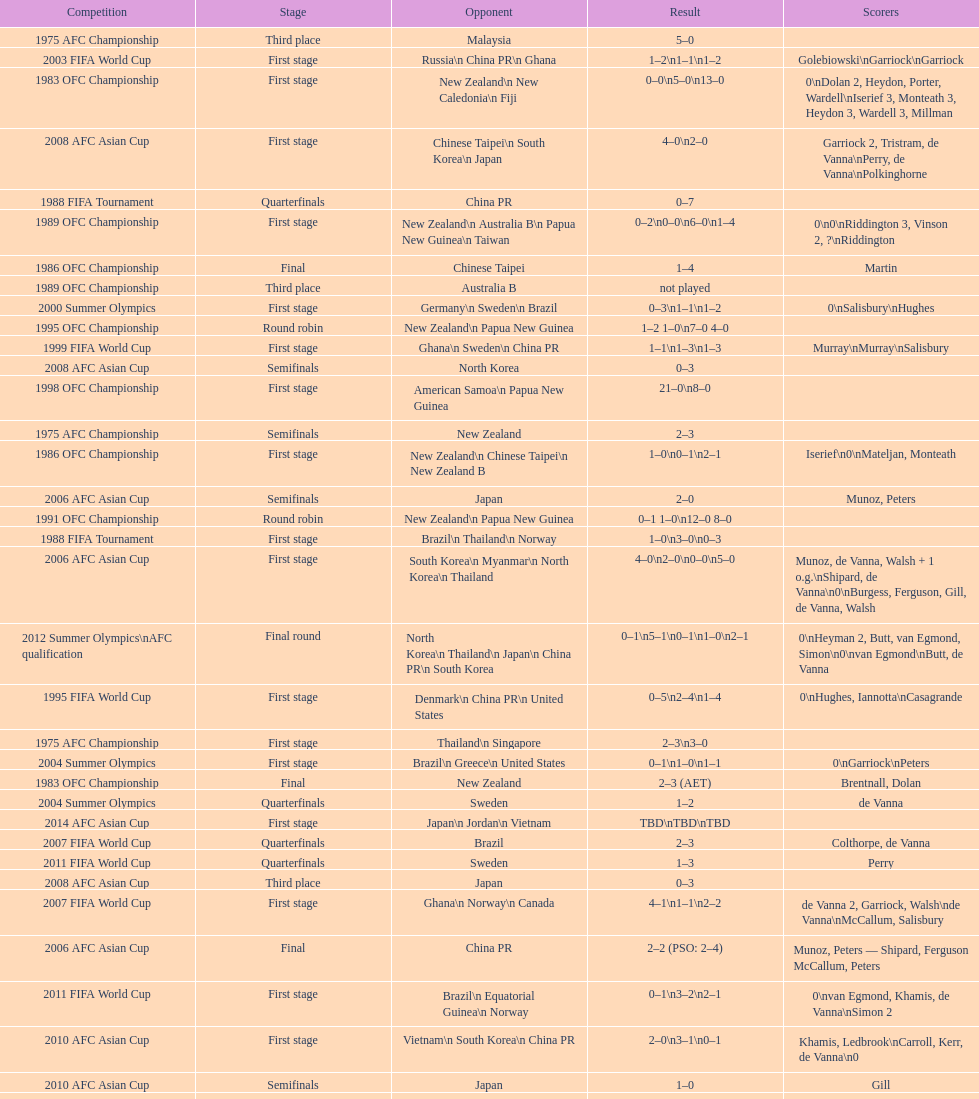What was the total goals made in the 1983 ofc championship? 18. 